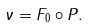Convert formula to latex. <formula><loc_0><loc_0><loc_500><loc_500>\nu = F _ { 0 } \circ P .</formula> 